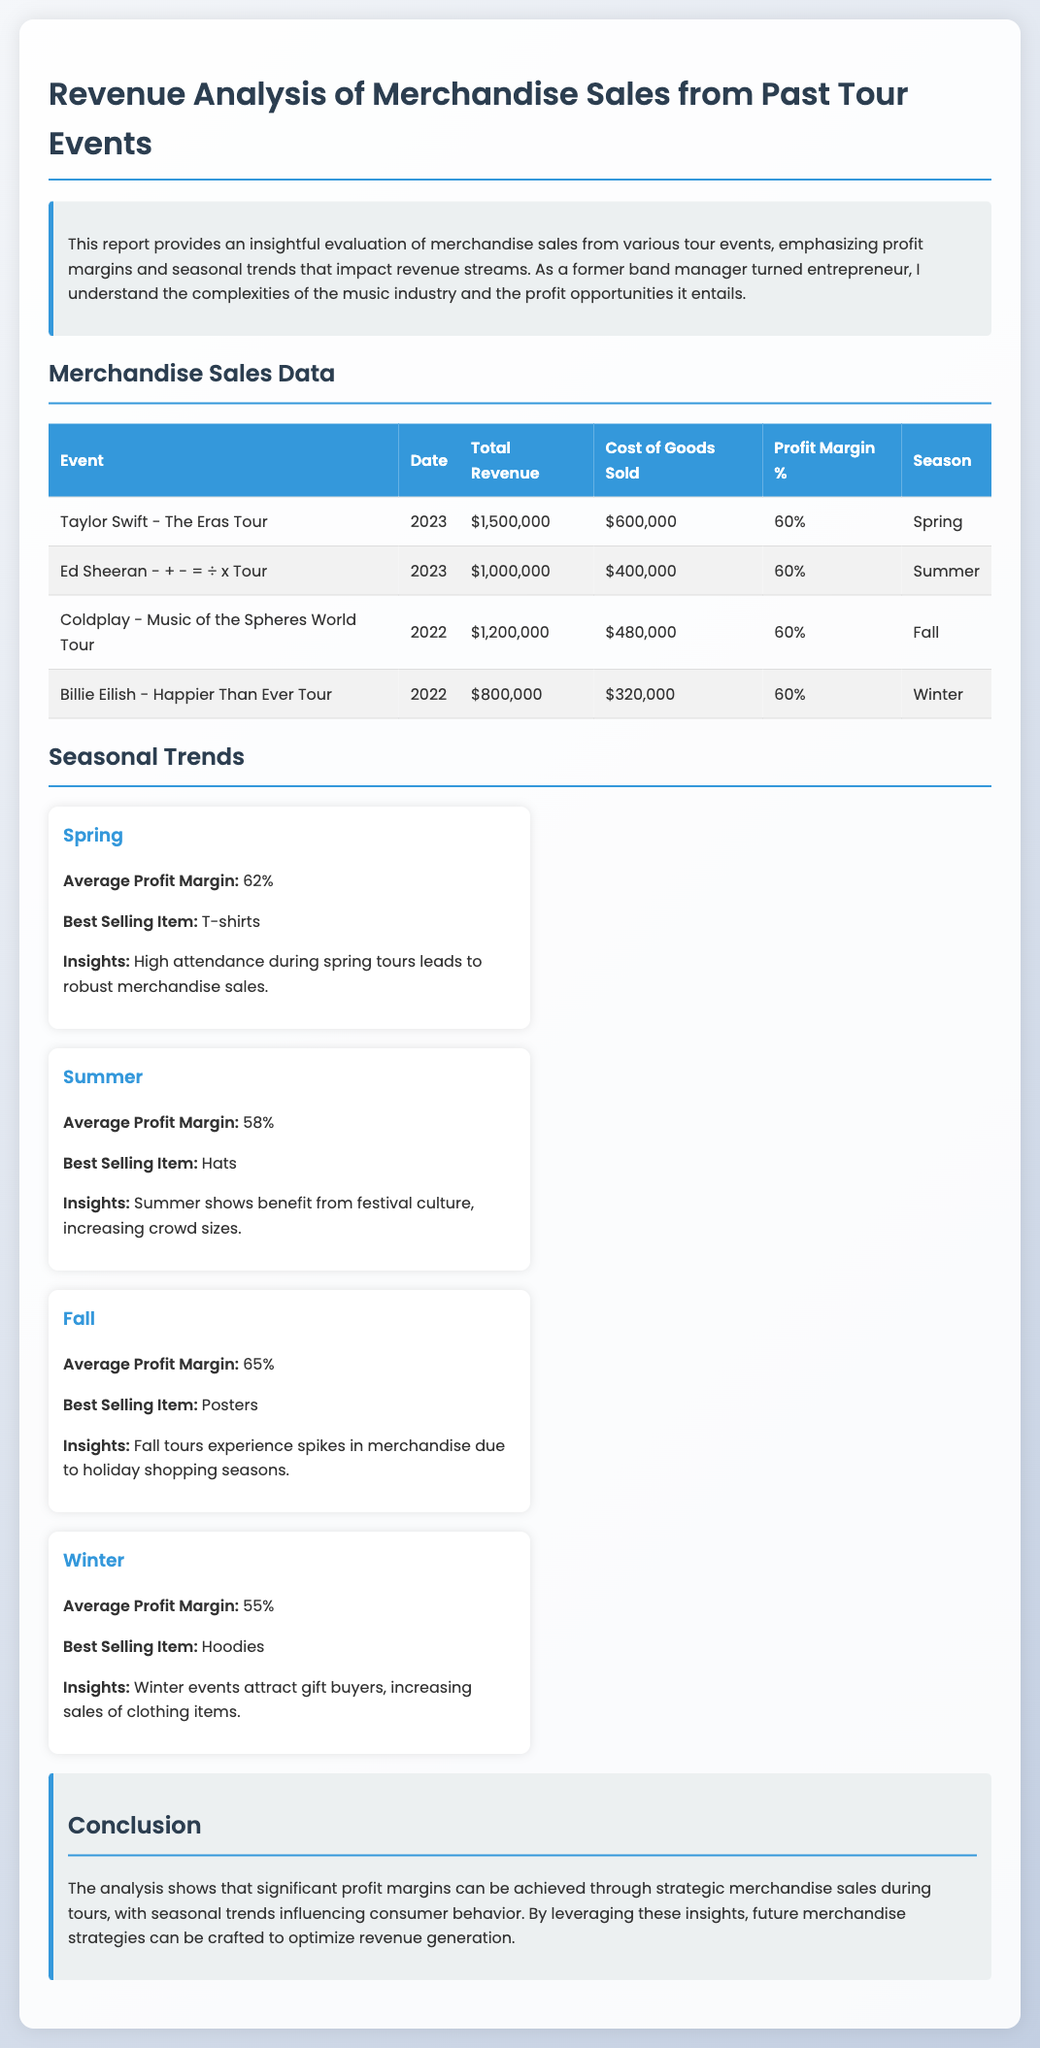What was the total revenue for the Taylor Swift event? The total revenue for the Taylor Swift event is specified in the table, which shows $1,500,000.
Answer: $1,500,000 What is the profit margin percentage for the Ed Sheeran tour? The document indicates that the profit margin for the Ed Sheeran tour is 60%.
Answer: 60% Which season had the highest average profit margin? The text states that Fall had the highest average profit margin of 65%.
Answer: Fall What was the best selling item for Winter? The document mentions the best selling item in Winter is Hoodies.
Answer: Hoodies How much was the total cost of goods sold for the Billie Eilish event? The cost of goods sold is detailed in the merchandise sales table, which lists $320,000 for Billie Eilish.
Answer: $320,000 What is one key insight for Spring merchandise sales? The document highlights that high attendance during spring tours leads to robust merchandise sales as a key insight.
Answer: High attendance How does the average profit margin for Summer compare to that of Spring? The Summer average profit margin is 58%, whereas Spring's is 62%, indicating Spring has a higher margin.
Answer: Spring has a higher margin What is the total revenue for all events combined? By summing the total revenue of all events listed, we find the combined total revenue to be $4,500,000.
Answer: $4,500,000 What unique merchandising strategy can be inferred for the Fall season? The document suggests leveraging holiday shopping seasons as a strategy for Fall.
Answer: Holiday shopping seasons 